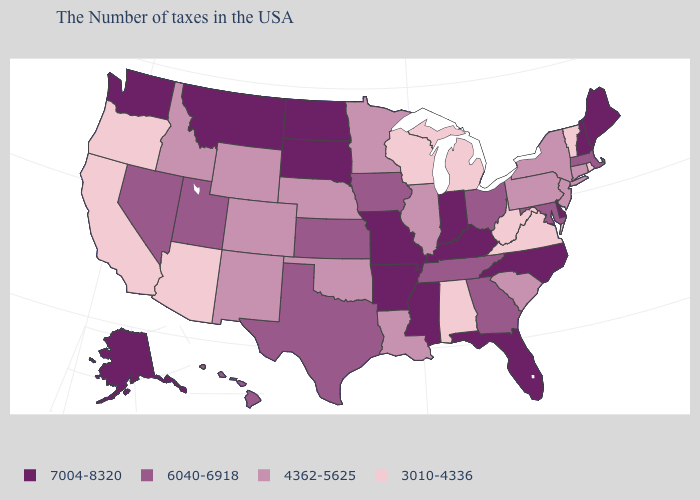Name the states that have a value in the range 7004-8320?
Concise answer only. Maine, New Hampshire, Delaware, North Carolina, Florida, Kentucky, Indiana, Mississippi, Missouri, Arkansas, South Dakota, North Dakota, Montana, Washington, Alaska. Name the states that have a value in the range 6040-6918?
Keep it brief. Massachusetts, Maryland, Ohio, Georgia, Tennessee, Iowa, Kansas, Texas, Utah, Nevada, Hawaii. Among the states that border Wyoming , does South Dakota have the highest value?
Be succinct. Yes. What is the value of Idaho?
Quick response, please. 4362-5625. What is the highest value in the USA?
Be succinct. 7004-8320. What is the value of New Hampshire?
Write a very short answer. 7004-8320. What is the highest value in states that border Oregon?
Answer briefly. 7004-8320. Which states have the lowest value in the USA?
Give a very brief answer. Rhode Island, Vermont, Virginia, West Virginia, Michigan, Alabama, Wisconsin, Arizona, California, Oregon. Does the first symbol in the legend represent the smallest category?
Concise answer only. No. Among the states that border Louisiana , does Texas have the highest value?
Quick response, please. No. What is the value of North Dakota?
Answer briefly. 7004-8320. Among the states that border New York , which have the lowest value?
Be succinct. Vermont. What is the highest value in the USA?
Give a very brief answer. 7004-8320. Among the states that border South Dakota , does North Dakota have the highest value?
Answer briefly. Yes. Name the states that have a value in the range 3010-4336?
Answer briefly. Rhode Island, Vermont, Virginia, West Virginia, Michigan, Alabama, Wisconsin, Arizona, California, Oregon. 